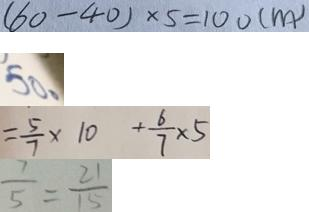Convert formula to latex. <formula><loc_0><loc_0><loc_500><loc_500>( 6 0 - 4 0 ) \times 5 = 1 0 0 ( m ) 
 5 0 。 
 = \frac { 5 } { 7 } \times 1 0 + \frac { 6 } { 7 } \times 5 
 \frac { 7 } { 5 } = \frac { 2 1 } { 1 5 }</formula> 